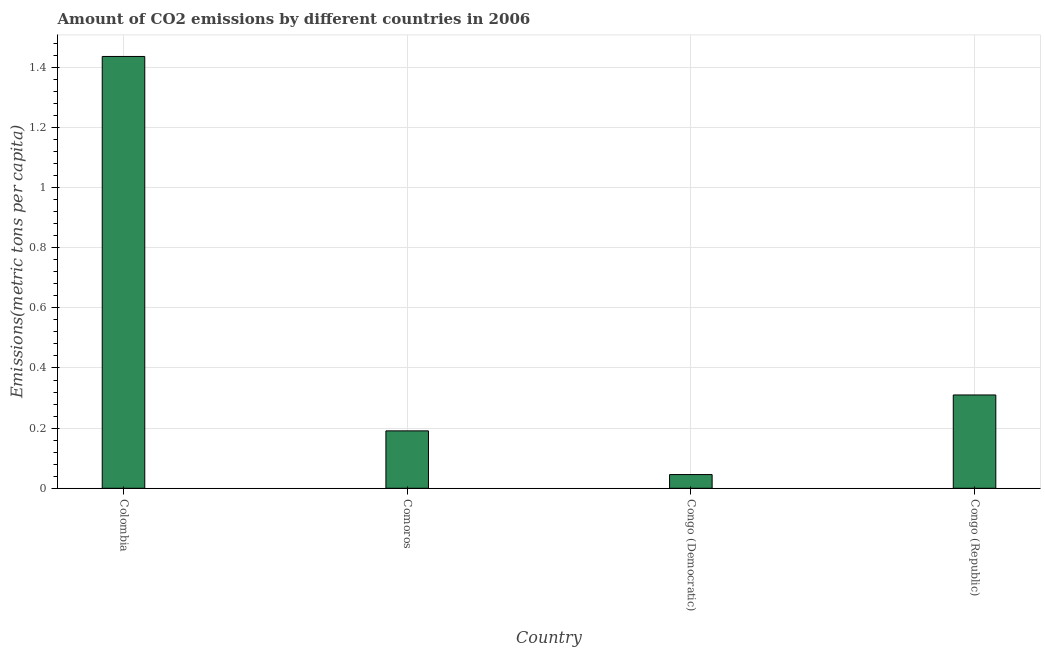Does the graph contain any zero values?
Offer a very short reply. No. Does the graph contain grids?
Make the answer very short. Yes. What is the title of the graph?
Offer a terse response. Amount of CO2 emissions by different countries in 2006. What is the label or title of the Y-axis?
Your answer should be very brief. Emissions(metric tons per capita). What is the amount of co2 emissions in Colombia?
Ensure brevity in your answer.  1.44. Across all countries, what is the maximum amount of co2 emissions?
Give a very brief answer. 1.44. Across all countries, what is the minimum amount of co2 emissions?
Keep it short and to the point. 0.05. In which country was the amount of co2 emissions maximum?
Keep it short and to the point. Colombia. In which country was the amount of co2 emissions minimum?
Offer a terse response. Congo (Democratic). What is the sum of the amount of co2 emissions?
Keep it short and to the point. 1.98. What is the difference between the amount of co2 emissions in Colombia and Congo (Democratic)?
Offer a terse response. 1.39. What is the average amount of co2 emissions per country?
Your response must be concise. 0.5. What is the median amount of co2 emissions?
Provide a succinct answer. 0.25. In how many countries, is the amount of co2 emissions greater than 0.84 metric tons per capita?
Offer a very short reply. 1. What is the ratio of the amount of co2 emissions in Comoros to that in Congo (Republic)?
Give a very brief answer. 0.61. Is the amount of co2 emissions in Comoros less than that in Congo (Republic)?
Make the answer very short. Yes. What is the difference between the highest and the second highest amount of co2 emissions?
Your answer should be very brief. 1.13. Is the sum of the amount of co2 emissions in Colombia and Congo (Republic) greater than the maximum amount of co2 emissions across all countries?
Keep it short and to the point. Yes. What is the difference between the highest and the lowest amount of co2 emissions?
Give a very brief answer. 1.39. In how many countries, is the amount of co2 emissions greater than the average amount of co2 emissions taken over all countries?
Your response must be concise. 1. How many countries are there in the graph?
Your answer should be compact. 4. What is the difference between two consecutive major ticks on the Y-axis?
Make the answer very short. 0.2. Are the values on the major ticks of Y-axis written in scientific E-notation?
Your answer should be compact. No. What is the Emissions(metric tons per capita) in Colombia?
Provide a succinct answer. 1.44. What is the Emissions(metric tons per capita) in Comoros?
Make the answer very short. 0.19. What is the Emissions(metric tons per capita) in Congo (Democratic)?
Keep it short and to the point. 0.05. What is the Emissions(metric tons per capita) of Congo (Republic)?
Your answer should be very brief. 0.31. What is the difference between the Emissions(metric tons per capita) in Colombia and Comoros?
Keep it short and to the point. 1.24. What is the difference between the Emissions(metric tons per capita) in Colombia and Congo (Democratic)?
Offer a terse response. 1.39. What is the difference between the Emissions(metric tons per capita) in Colombia and Congo (Republic)?
Ensure brevity in your answer.  1.13. What is the difference between the Emissions(metric tons per capita) in Comoros and Congo (Democratic)?
Your response must be concise. 0.15. What is the difference between the Emissions(metric tons per capita) in Comoros and Congo (Republic)?
Provide a short and direct response. -0.12. What is the difference between the Emissions(metric tons per capita) in Congo (Democratic) and Congo (Republic)?
Your response must be concise. -0.26. What is the ratio of the Emissions(metric tons per capita) in Colombia to that in Comoros?
Make the answer very short. 7.52. What is the ratio of the Emissions(metric tons per capita) in Colombia to that in Congo (Democratic)?
Make the answer very short. 31.5. What is the ratio of the Emissions(metric tons per capita) in Colombia to that in Congo (Republic)?
Offer a terse response. 4.63. What is the ratio of the Emissions(metric tons per capita) in Comoros to that in Congo (Democratic)?
Offer a very short reply. 4.19. What is the ratio of the Emissions(metric tons per capita) in Comoros to that in Congo (Republic)?
Give a very brief answer. 0.61. What is the ratio of the Emissions(metric tons per capita) in Congo (Democratic) to that in Congo (Republic)?
Keep it short and to the point. 0.15. 